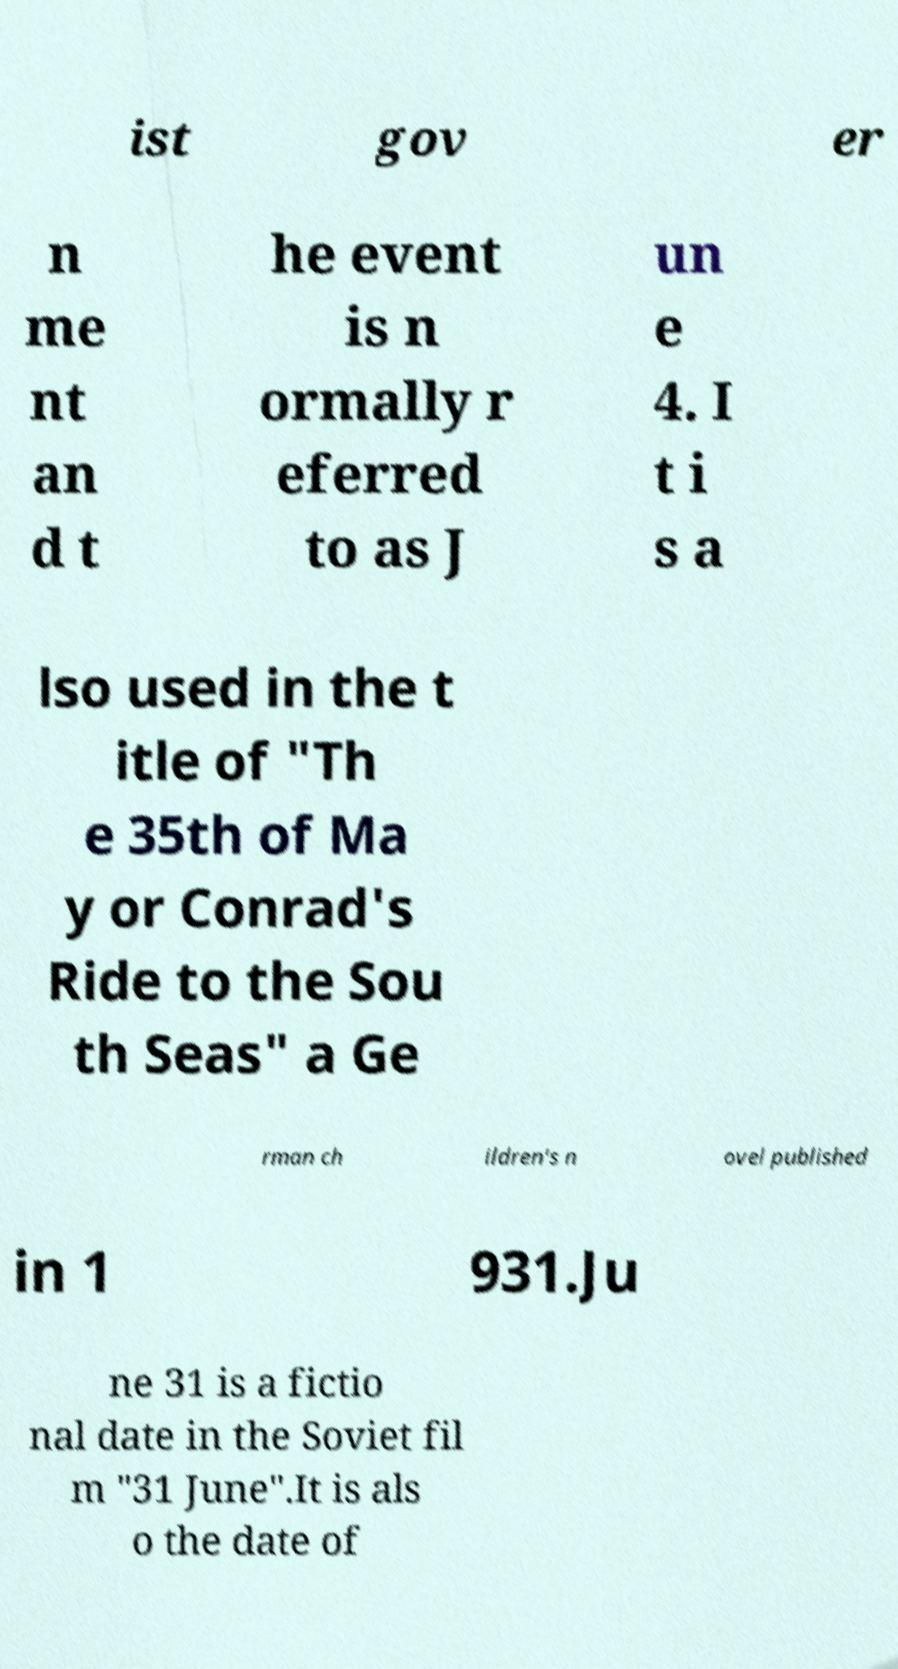Please read and relay the text visible in this image. What does it say? ist gov er n me nt an d t he event is n ormally r eferred to as J un e 4. I t i s a lso used in the t itle of "Th e 35th of Ma y or Conrad's Ride to the Sou th Seas" a Ge rman ch ildren's n ovel published in 1 931.Ju ne 31 is a fictio nal date in the Soviet fil m "31 June".It is als o the date of 